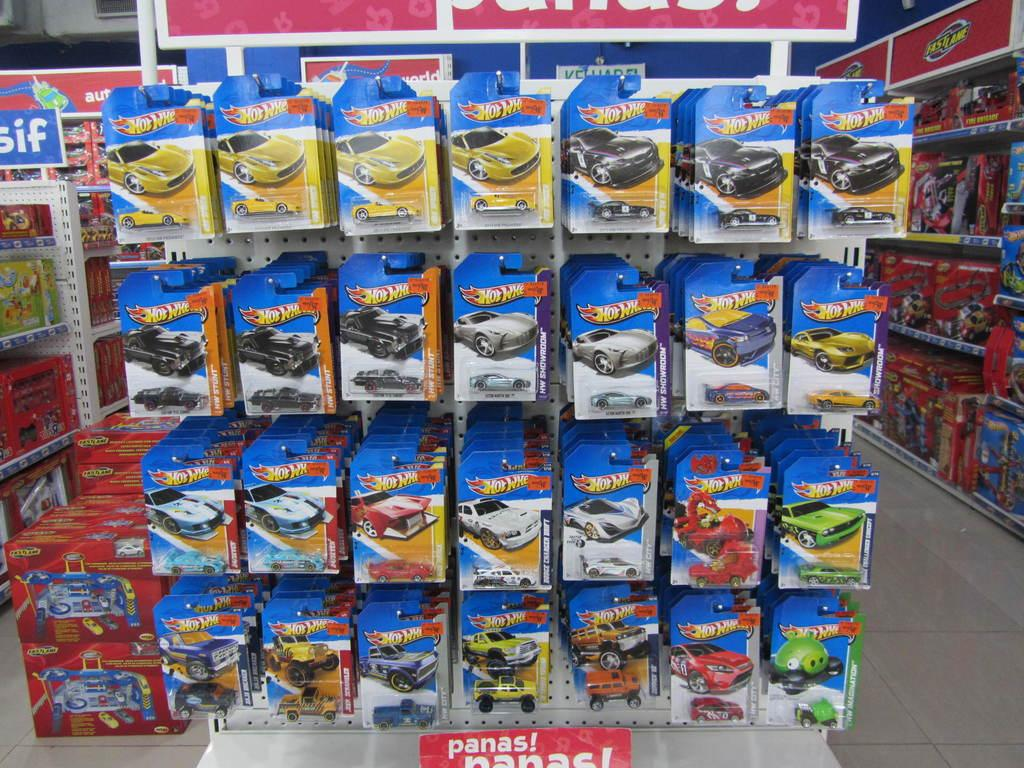Provide a one-sentence caption for the provided image. A row of hot wheel cars are lined up over a sign in a toy store that says Panas. 